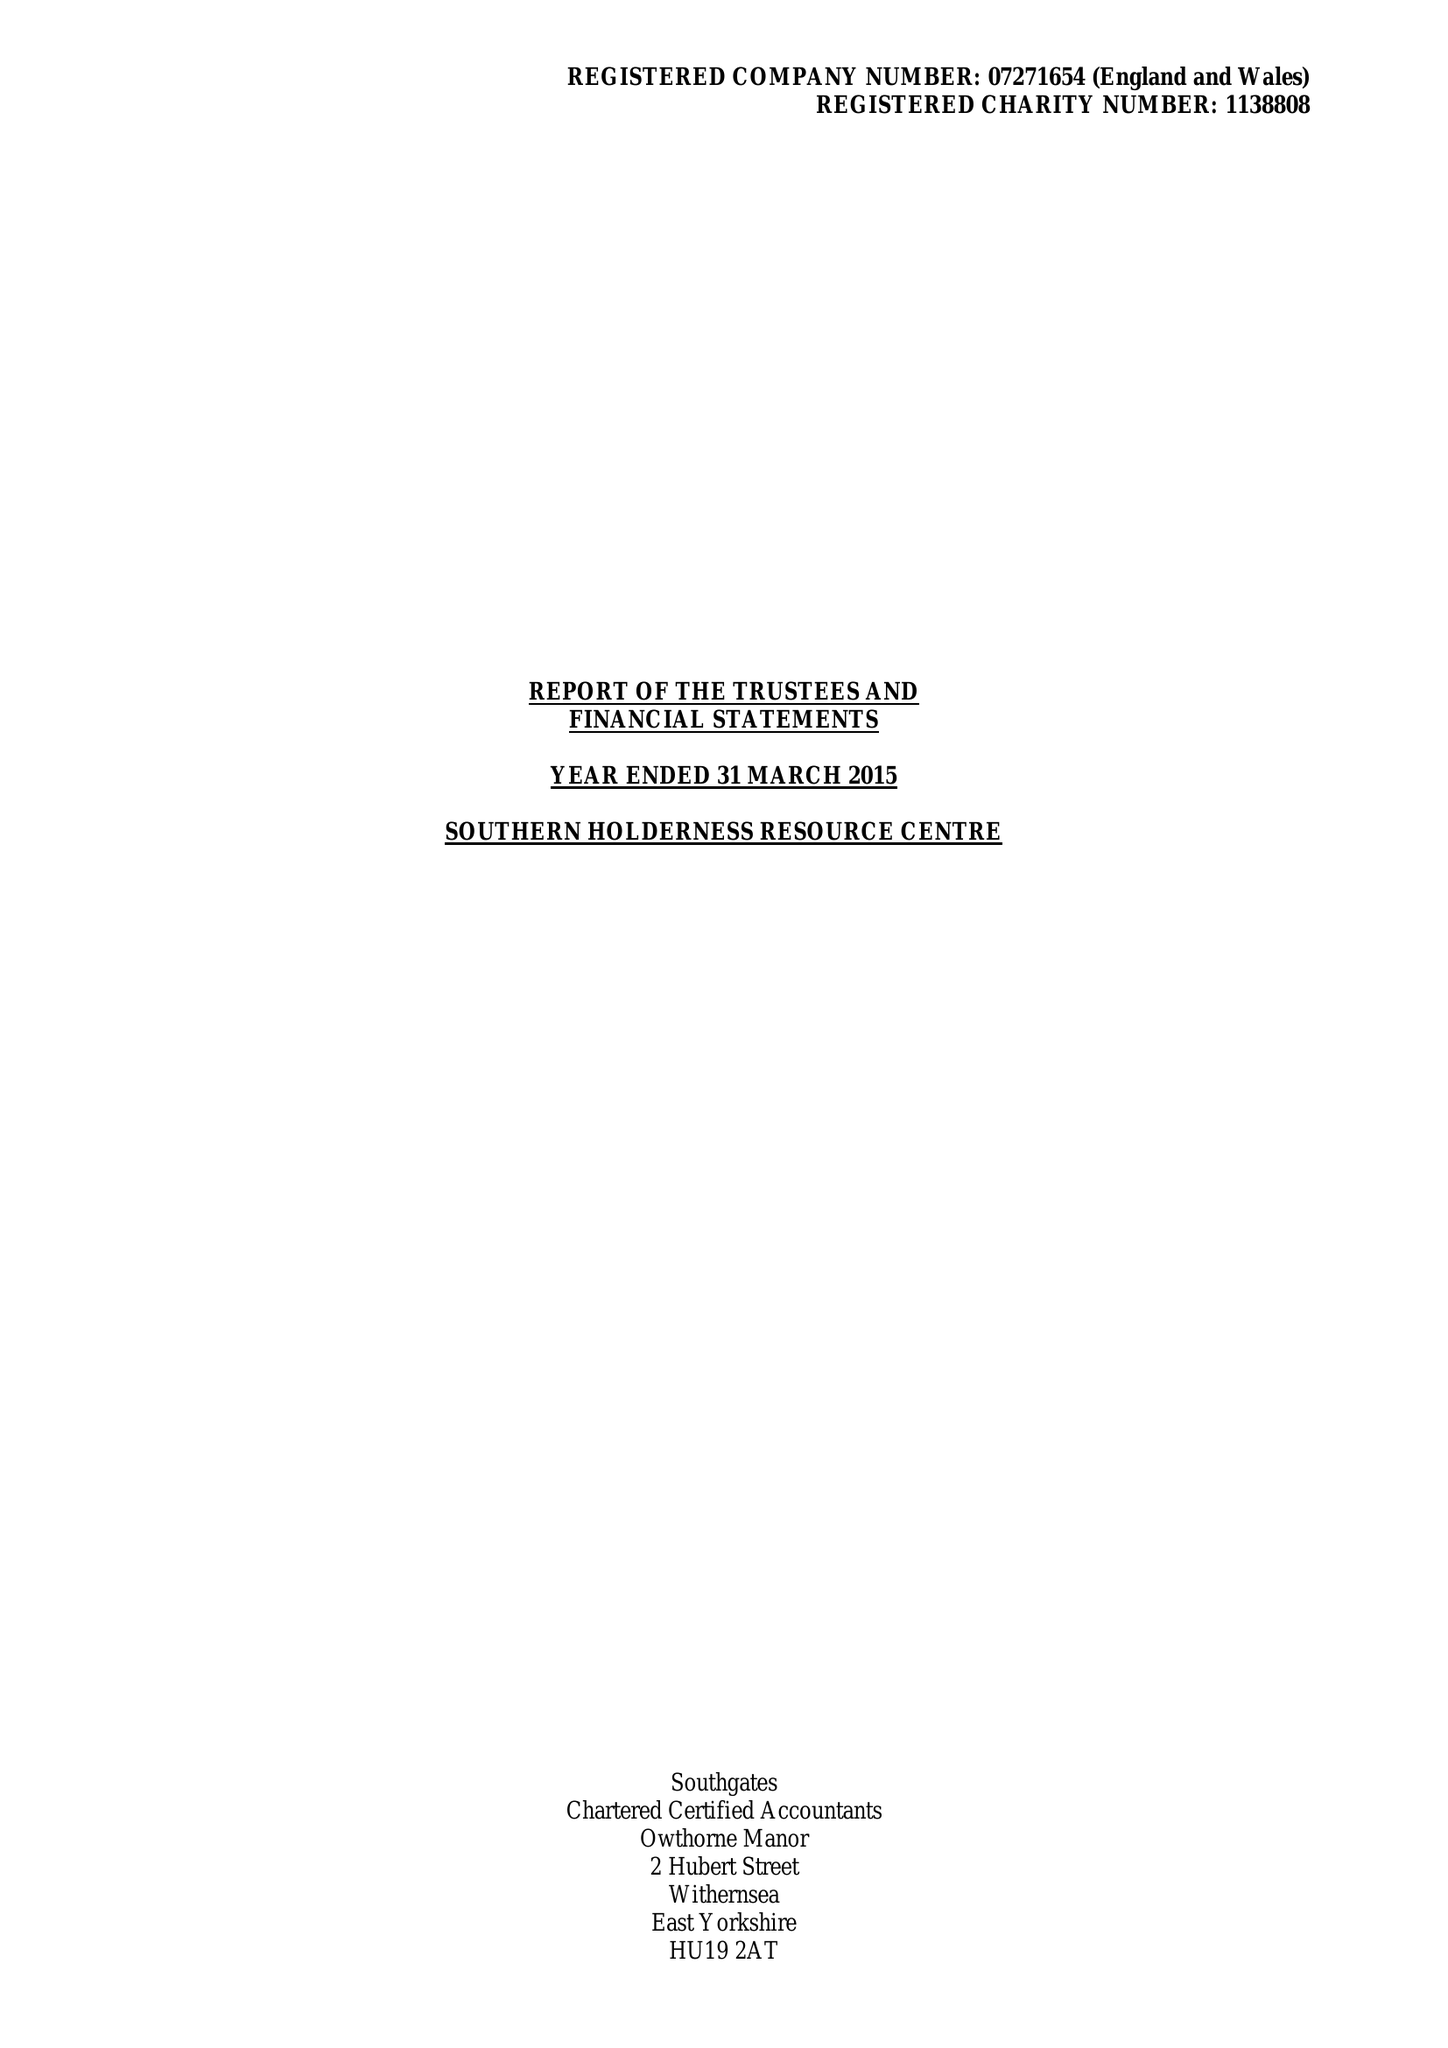What is the value for the report_date?
Answer the question using a single word or phrase. 2015-03-31 